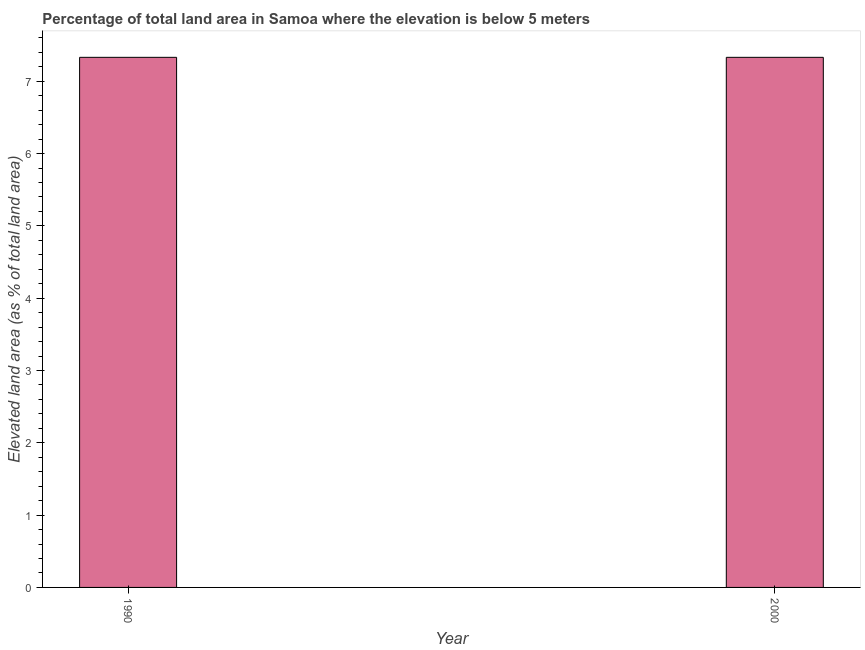What is the title of the graph?
Give a very brief answer. Percentage of total land area in Samoa where the elevation is below 5 meters. What is the label or title of the X-axis?
Offer a terse response. Year. What is the label or title of the Y-axis?
Provide a short and direct response. Elevated land area (as % of total land area). What is the total elevated land area in 2000?
Ensure brevity in your answer.  7.33. Across all years, what is the maximum total elevated land area?
Your response must be concise. 7.33. Across all years, what is the minimum total elevated land area?
Make the answer very short. 7.33. In which year was the total elevated land area maximum?
Give a very brief answer. 1990. In which year was the total elevated land area minimum?
Your answer should be very brief. 1990. What is the sum of the total elevated land area?
Ensure brevity in your answer.  14.66. What is the difference between the total elevated land area in 1990 and 2000?
Make the answer very short. 0. What is the average total elevated land area per year?
Give a very brief answer. 7.33. What is the median total elevated land area?
Keep it short and to the point. 7.33. In how many years, is the total elevated land area greater than 1.4 %?
Offer a very short reply. 2. In how many years, is the total elevated land area greater than the average total elevated land area taken over all years?
Give a very brief answer. 0. Are all the bars in the graph horizontal?
Make the answer very short. No. Are the values on the major ticks of Y-axis written in scientific E-notation?
Keep it short and to the point. No. What is the Elevated land area (as % of total land area) of 1990?
Provide a short and direct response. 7.33. What is the Elevated land area (as % of total land area) of 2000?
Give a very brief answer. 7.33. What is the difference between the Elevated land area (as % of total land area) in 1990 and 2000?
Offer a terse response. 0. What is the ratio of the Elevated land area (as % of total land area) in 1990 to that in 2000?
Your response must be concise. 1. 